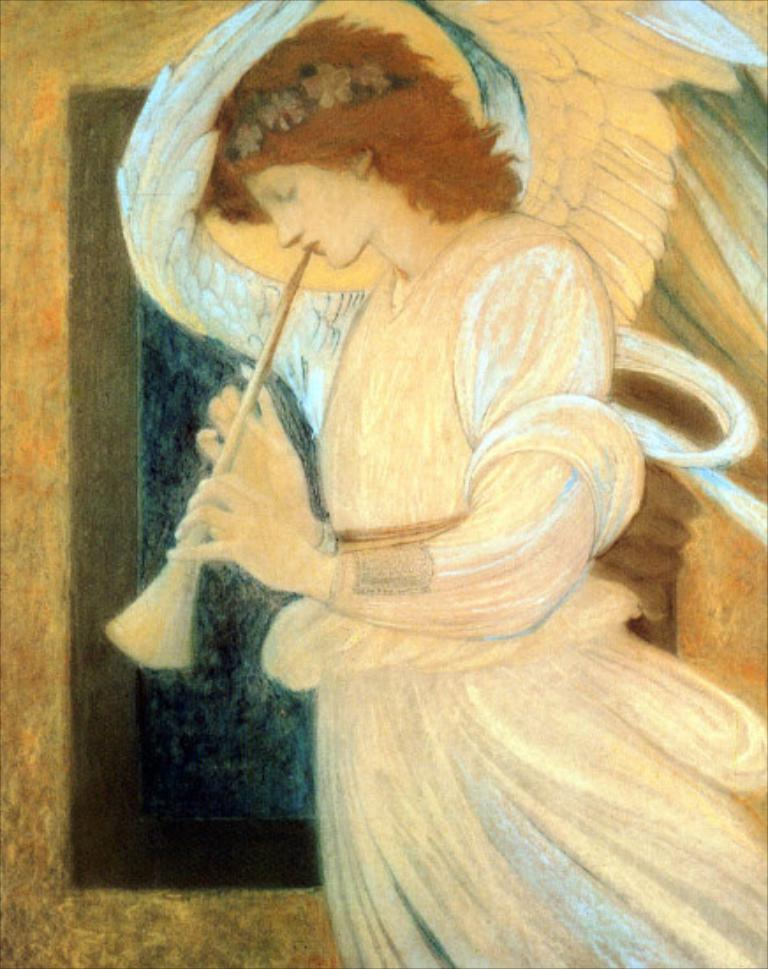What is the main subject of the image? There is a painting in the image. What is depicted in the painting? The painting depicts a lady. What is the lady doing in the painting? The lady is holding an object in the painting. What type of flame can be seen in the painting? There is no flame present in the painting; it depicts a lady holding an object. What company is associated with the lady in the painting? There is no company mentioned or depicted in the painting; it only shows a lady holding an object. 